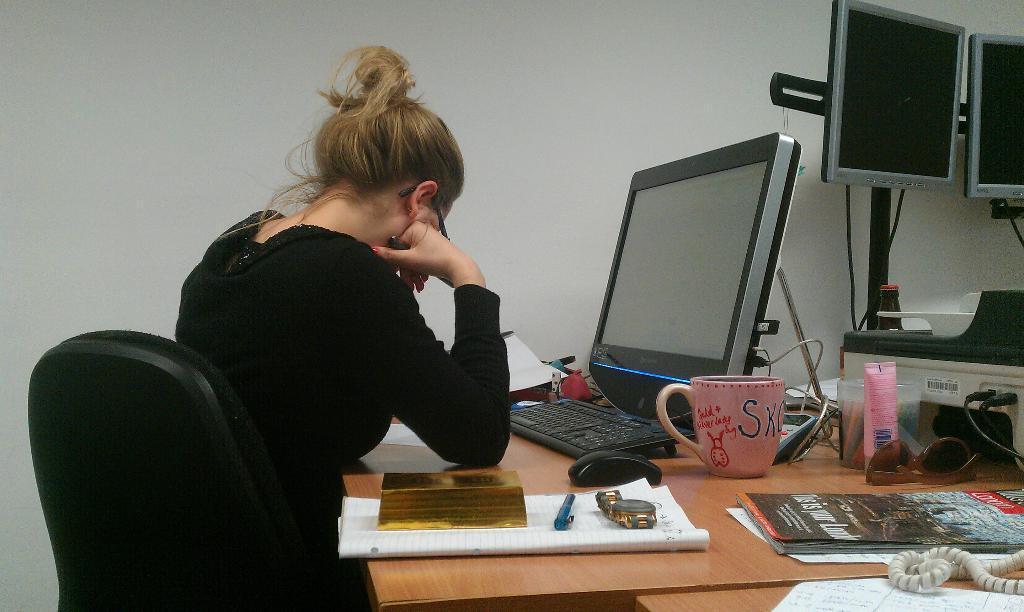In one or two sentences, can you explain what this image depicts? This is the picture inside the room. There is a woman sitting on the chair. There is a computer, keyboard, cup, mouse, book, watch, penn, telephone, goggles, wires on the table. 